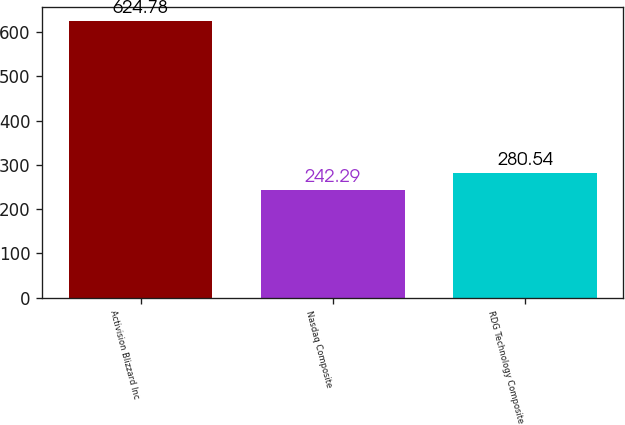<chart> <loc_0><loc_0><loc_500><loc_500><bar_chart><fcel>Activision Blizzard Inc<fcel>Nasdaq Composite<fcel>RDG Technology Composite<nl><fcel>624.78<fcel>242.29<fcel>280.54<nl></chart> 